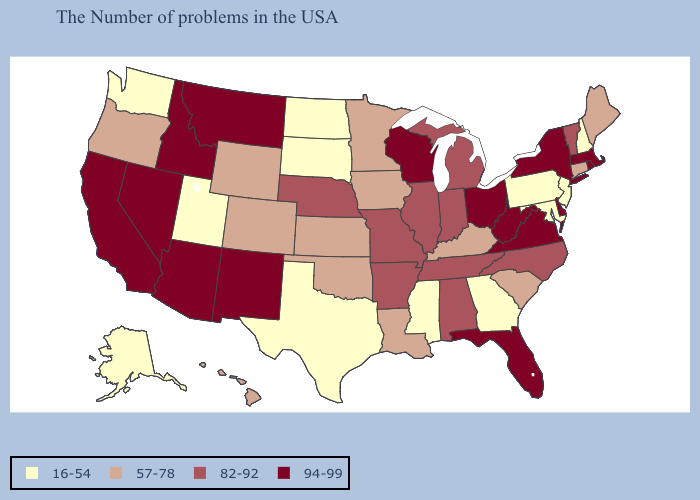Is the legend a continuous bar?
Short answer required. No. Among the states that border Virginia , does North Carolina have the lowest value?
Be succinct. No. Which states have the lowest value in the USA?
Keep it brief. New Hampshire, New Jersey, Maryland, Pennsylvania, Georgia, Mississippi, Texas, South Dakota, North Dakota, Utah, Washington, Alaska. Name the states that have a value in the range 16-54?
Quick response, please. New Hampshire, New Jersey, Maryland, Pennsylvania, Georgia, Mississippi, Texas, South Dakota, North Dakota, Utah, Washington, Alaska. Among the states that border New Mexico , which have the highest value?
Be succinct. Arizona. Among the states that border Utah , which have the lowest value?
Be succinct. Wyoming, Colorado. Does Pennsylvania have the lowest value in the Northeast?
Quick response, please. Yes. What is the value of Illinois?
Quick response, please. 82-92. Does Colorado have the highest value in the USA?
Concise answer only. No. Which states hav the highest value in the MidWest?
Be succinct. Ohio, Wisconsin. What is the value of Hawaii?
Keep it brief. 57-78. Among the states that border Georgia , does North Carolina have the lowest value?
Write a very short answer. No. Name the states that have a value in the range 94-99?
Short answer required. Massachusetts, Rhode Island, New York, Delaware, Virginia, West Virginia, Ohio, Florida, Wisconsin, New Mexico, Montana, Arizona, Idaho, Nevada, California. What is the value of Florida?
Short answer required. 94-99. What is the lowest value in the USA?
Keep it brief. 16-54. 